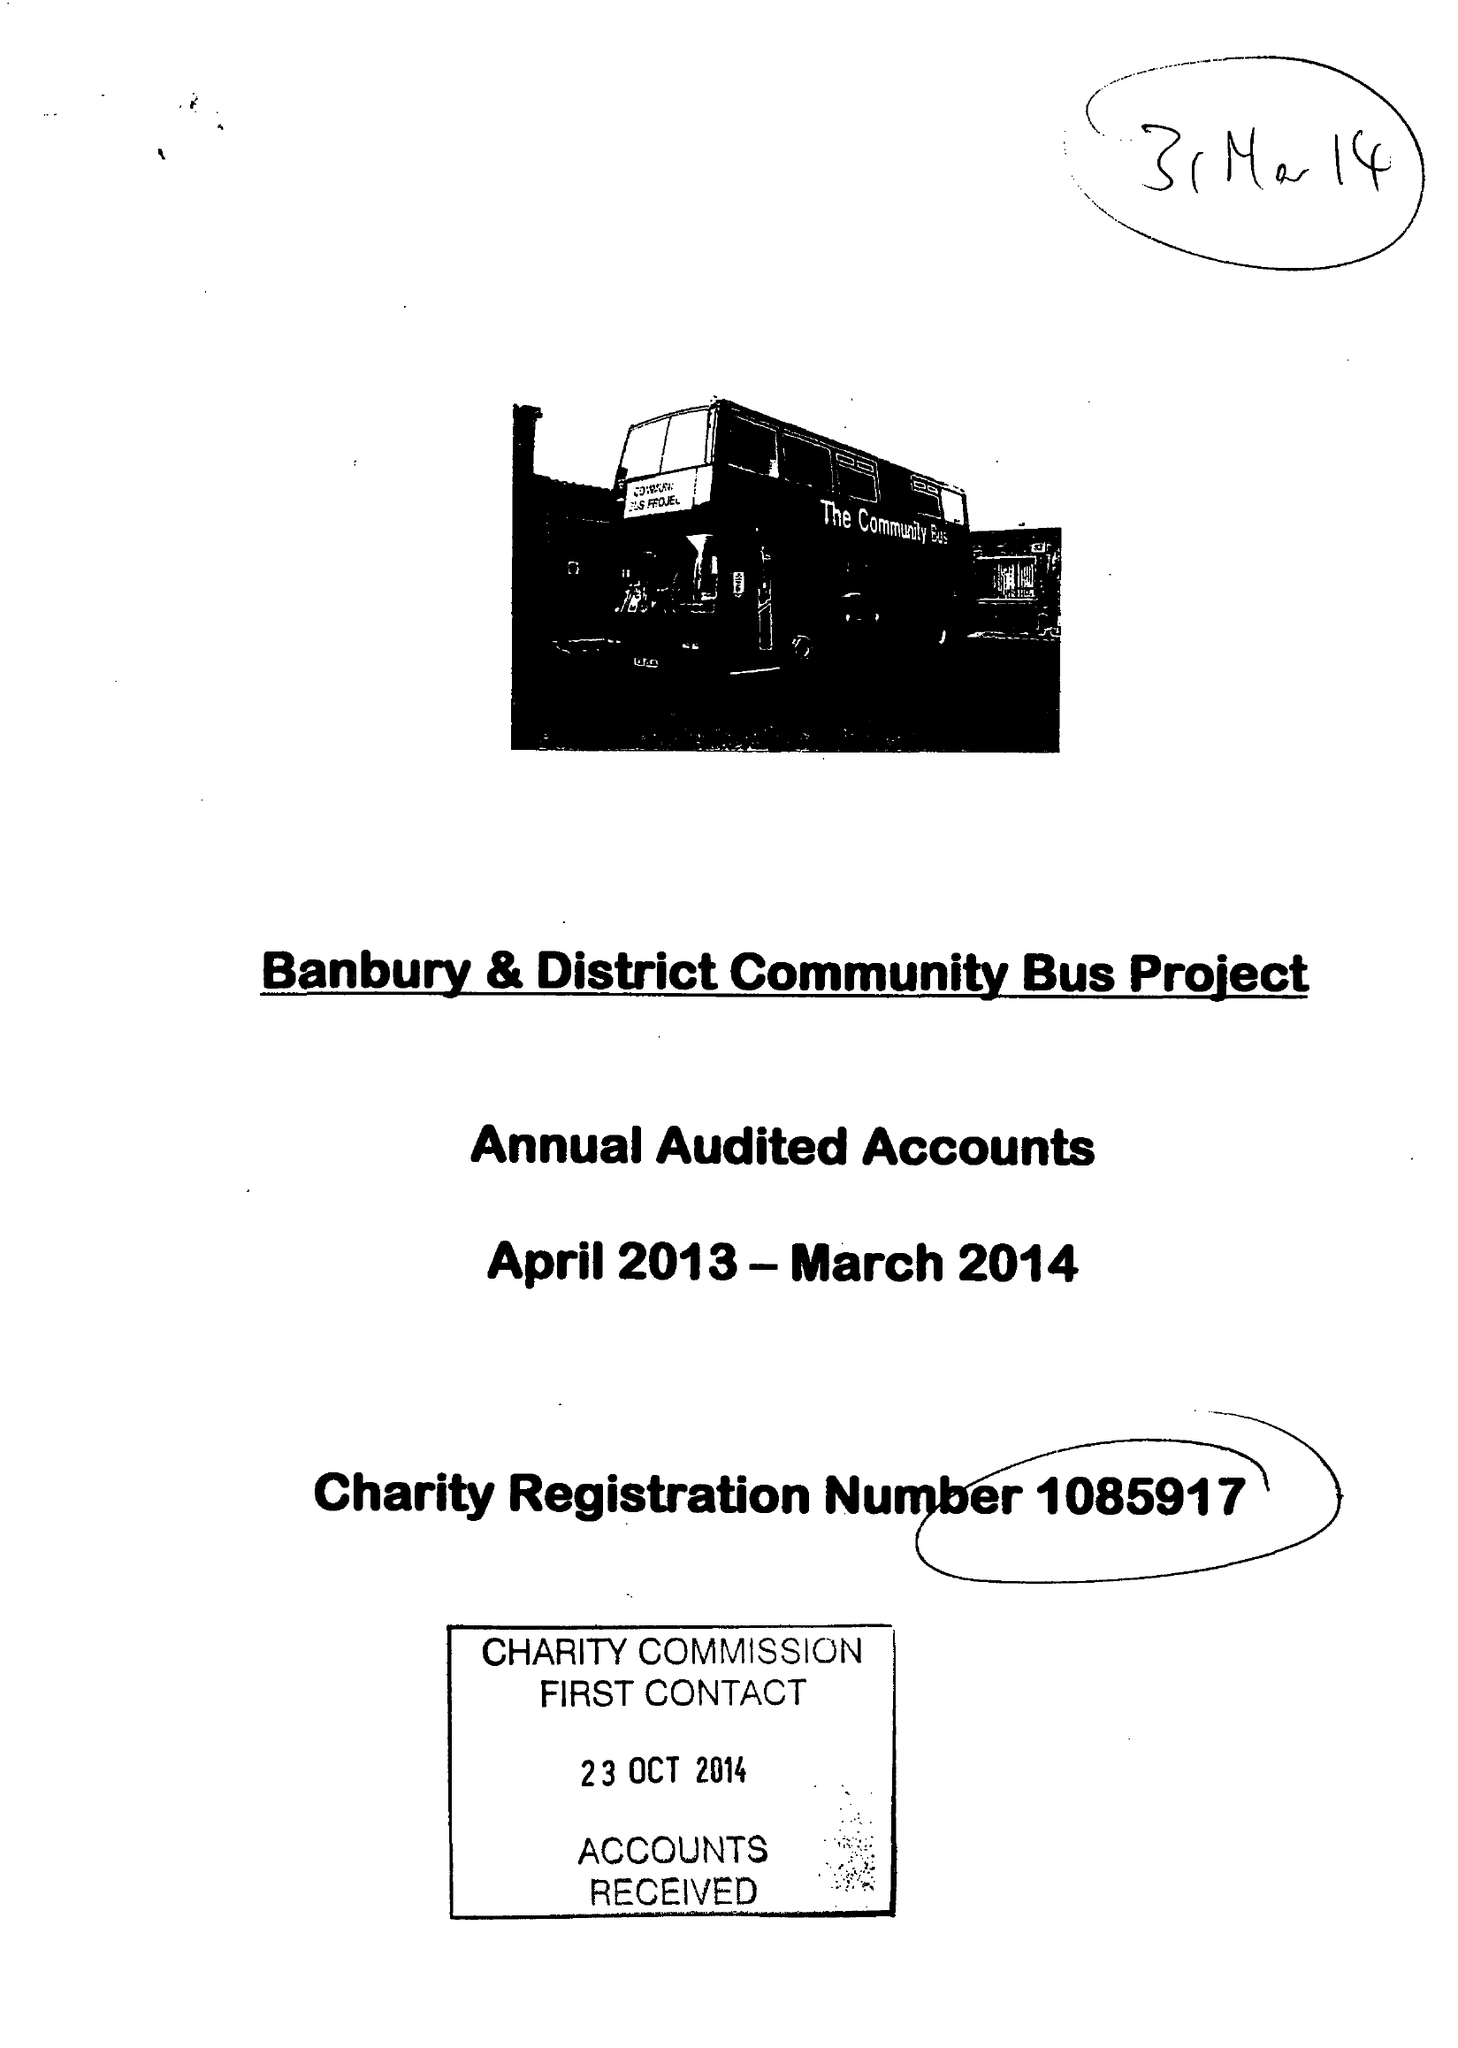What is the value for the address__post_town?
Answer the question using a single word or phrase. BANBURY 